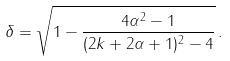Convert formula to latex. <formula><loc_0><loc_0><loc_500><loc_500>\delta = \sqrt { 1 - \frac { 4 \alpha ^ { 2 } - 1 } { ( 2 k + 2 \alpha + 1 ) ^ { 2 } - 4 } } \, .</formula> 